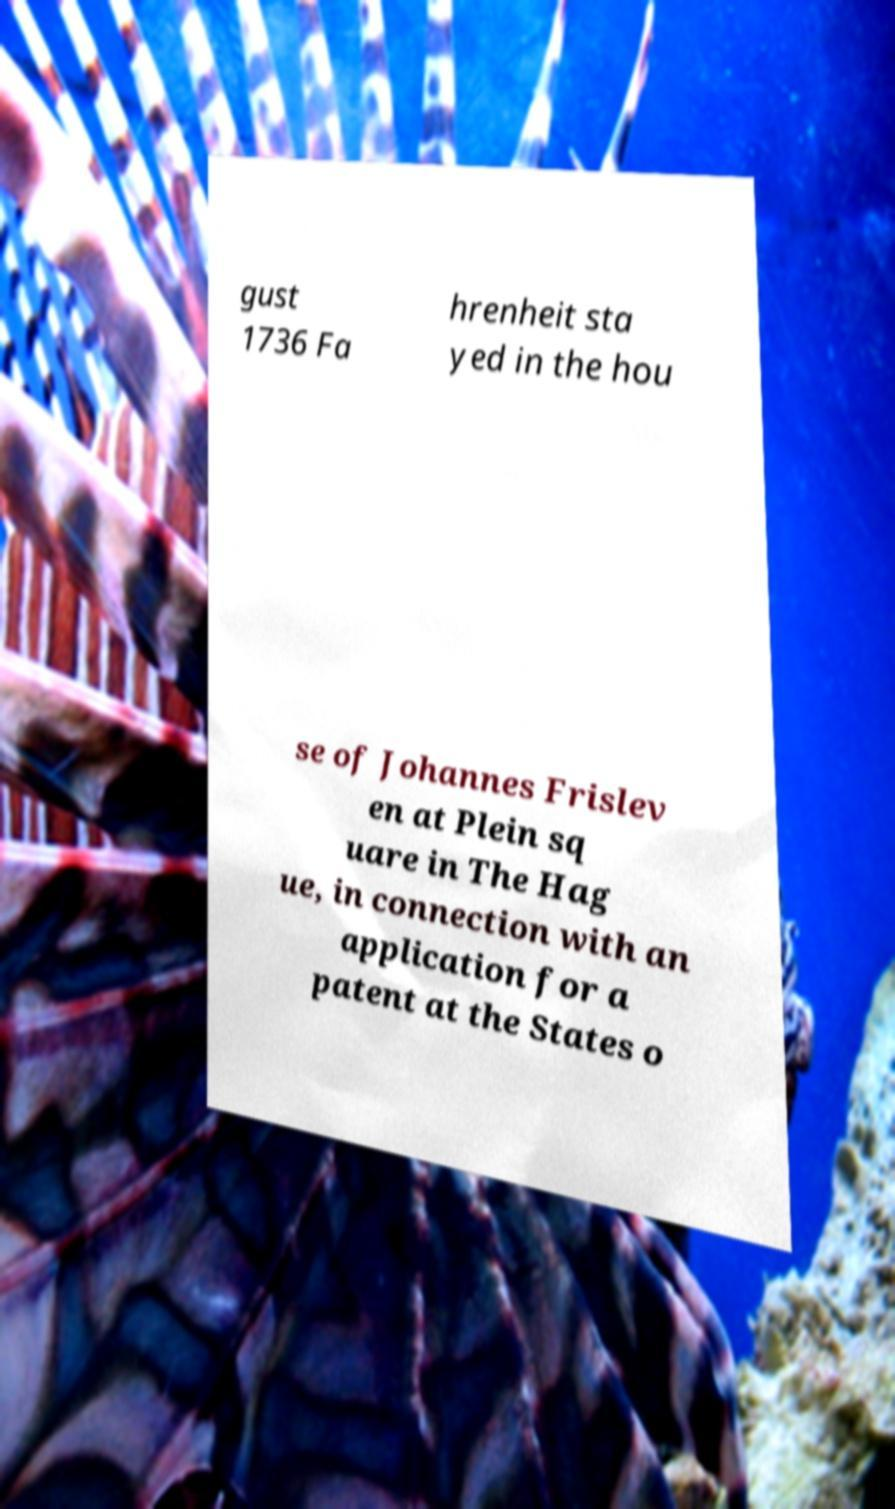I need the written content from this picture converted into text. Can you do that? gust 1736 Fa hrenheit sta yed in the hou se of Johannes Frislev en at Plein sq uare in The Hag ue, in connection with an application for a patent at the States o 